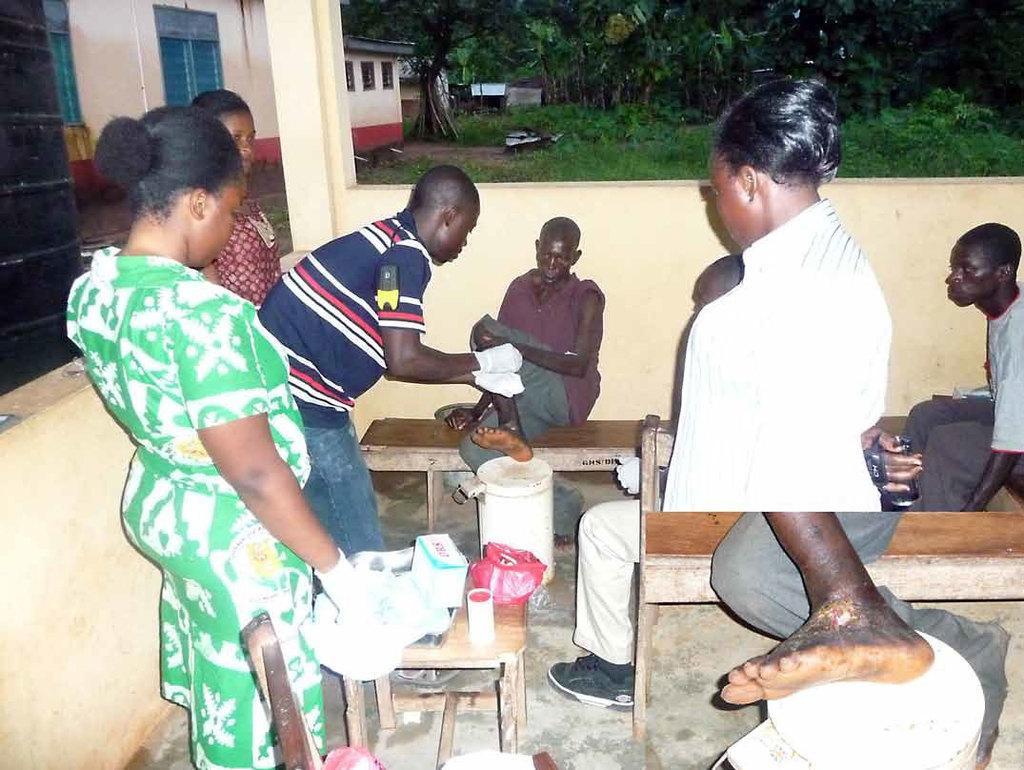In one or two sentences, can you explain what this image depicts? In the center of the image there is a man sitting on the bench. There is a table placed before him. There are people standing around him. On the left there are buildings. In the background there are trees and grass. 